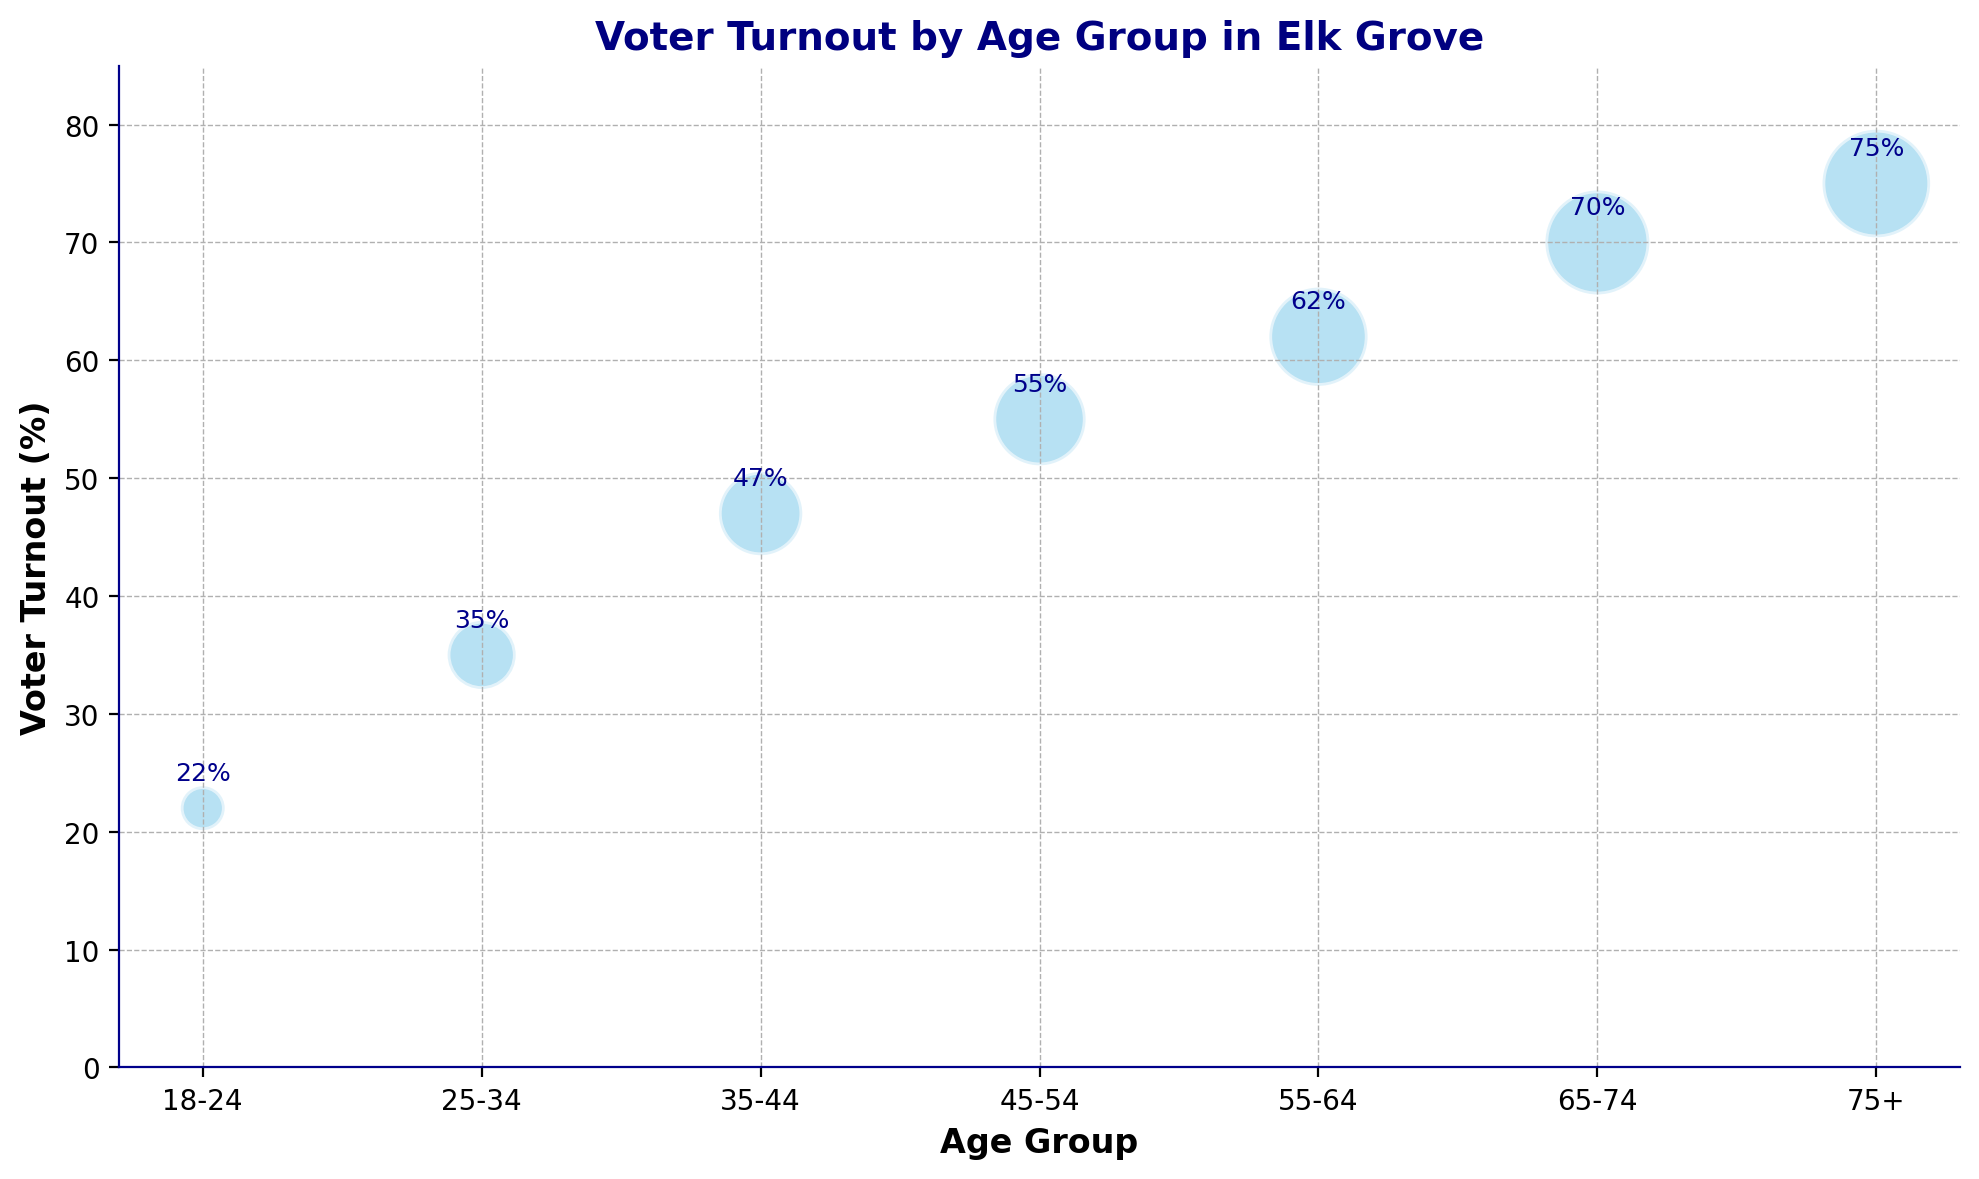What age group has the highest voter turnout percentage? When looking at the bubble chart, the highest voter turnout percentage among the age groups is identified by finding the highest positioned bubble on the vertical axis (Y-axis). The topmost bubble corresponds to the 75+ age group with a voter turnout of 75%.
Answer: 75+ Which age group has the smallest bubble size? To identify which age group has the smallest bubble size, we observe the smallest circle in the chart. The smallest bubble corresponds to the age group 18-24.
Answer: 18-24 How much more is the voter turnout for the 65-74 age group compared to the 18-24 age group? Subtract the voter turnout percentage of the 18-24 age group from that of the 65-74 age group. Voter turnout for 65-74 is 70%, and for 18-24, it is 22%. Therefore, 70% - 22% = 48%.
Answer: 48% What is the average voter turnout percentage for all age groups combined? To find the average voter turnout, sum up all the percentages and divide by the number of age groups. (22 + 35 + 47 + 55 + 62 + 70 + 75) / 7 = 52.28%.
Answer: 52.28% Which age group has a voter turnout percentage equal to the average bubble size value of 25? Locate the bubble where the voter turnout percentage matches the value 25, considering average bubble size given explicitly for reference purposes. In the data, 55-64 age group has the bubble size 25 which is also the closest voter turnout of 62%.
Answer: 55-64 Is the voter turnout for the 35-44 age group greater than the voter turnout for the 25-34 age group? If yes, by how much? Compare the voter turnout percentages: 35-44 age group (47%) and 25-34 age group (35%). 47% is greater, and subtracting these gives 47% - 35% = 12%.
Answer: 12% What is the median voter turnout percentage? Arrange the voter turnout percentages in numerical order: 22, 35, 47, 55, 62, 70, 75. The median is the middle value in this ordered list. The middle value is 55%.
Answer: 55% Which parameter of the bubble chart differentiates voter turnout among the age groups visually? The position of bubbles on the Y-axis indicates differing voter turnouts among the age groups, effectively showing turnout percentages.
Answer: Y-axis position Is the average voter turnout percentage for age groups over 55 years greater than the average voter turnout of all age groups? Calculate the average voter turnout for age groups over 55 years (55-64, 65-74, 75+) which is (62 + 70 + 75) / 3 = 69%. Compare this with the average turnout of all age groups 52.28%. 69% > 52.28%.
Answer: Yes Compare the bubble size of the youngest age group to the oldest age group. The youngest age group (18-24) has a bubble size of 5, while the oldest age group (75+) has a bubble size of 30.
Answer: 5 vs 30 